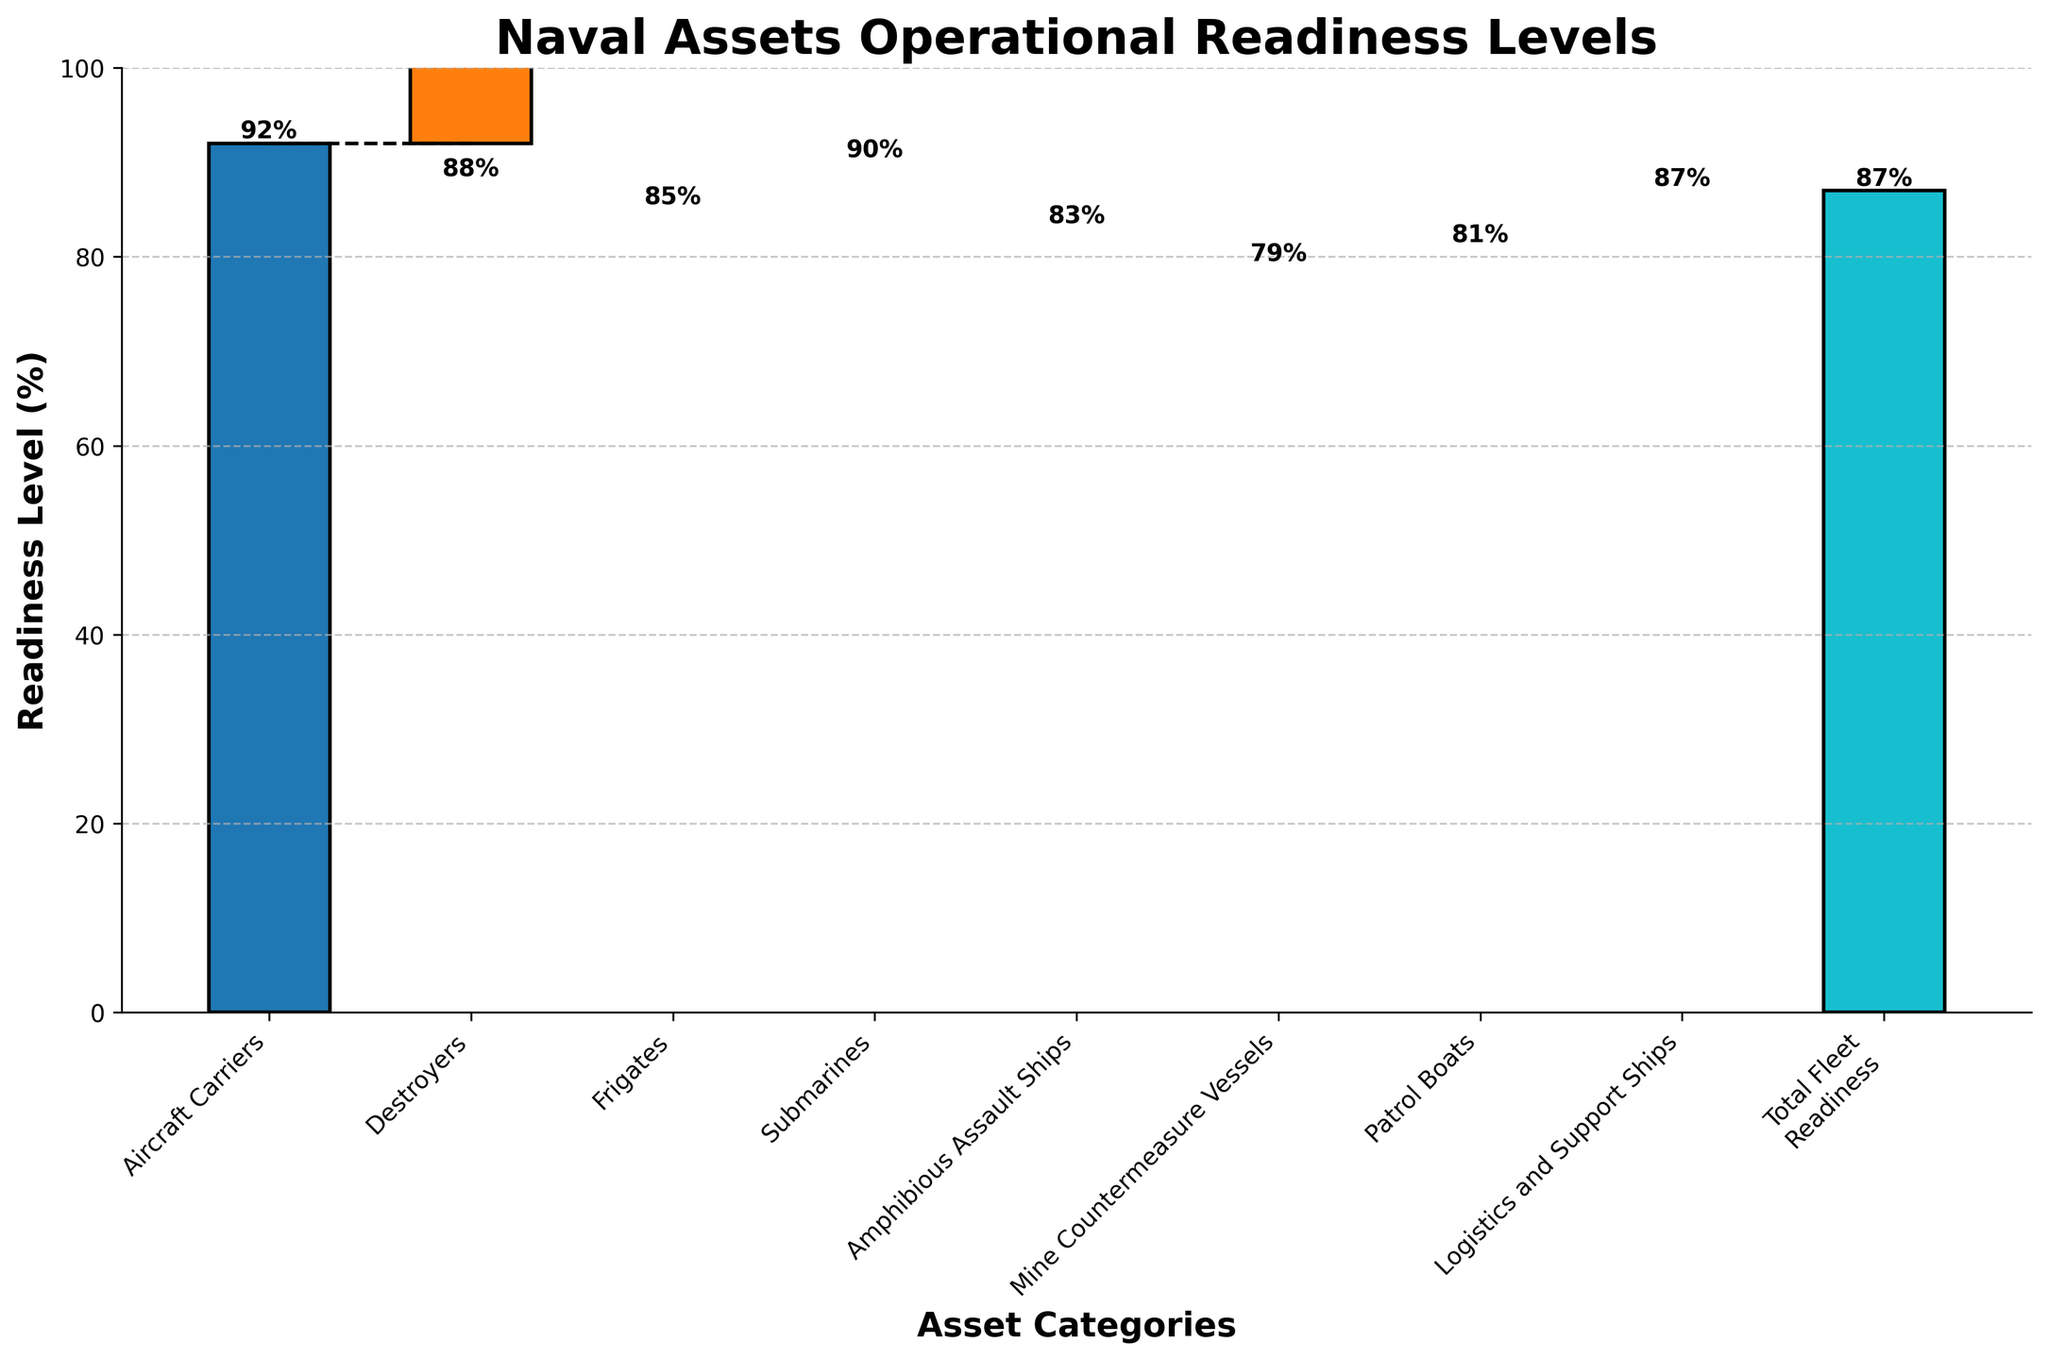How many asset categories are displayed in the chart? The chart shows the categories as bars on the x-axis and values for each bar. Counting the bars on the x-axis reveals the number of asset categories.
Answer: 8 Which asset category has the highest readiness level? Examine the heights of the bars; the tallest bar indicates the highest readiness level. The bar for Aircraft Carriers is the tallest.
Answer: Aircraft Carriers What is the title of the chart? The title is prominently displayed at the top of the chart.
Answer: Naval Assets Operational Readiness Levels What is the readiness level for Amphibious Assault Ships? The readiness levels are labeled above each bar. Find the label above the Amphibious Assault Ships bar.
Answer: 83 Calculate the average readiness level across all individual asset categories. Add the readiness levels of all individual categories and divide by the number of categories: (92 + 88 + 85 + 90 + 83 + 79 + 81 + 87) / 8.
Answer: 85.625 What is the difference in readiness levels between Submarines and Frigates? Find the readiness levels for Submarines and Frigates and subtract the smaller value from the larger one: 90 - 85.
Answer: 5 Which asset category has the lowest readiness level? Identify the shortest bar in the chart. The bar for Mine Countermeasure Vessels is the shortest.
Answer: Mine Countermeasure Vessels How does the readiness level of Logistics and Support Ships compare to that of Patrol Boats? Compare the heights of the respective bars. Logistics and Support Ships have a value of 87, while Patrol Boats have a value of 81. 87 is greater than 81.
Answer: Logistics and Support Ships have a higher readiness level than Patrol Boats What is the cumulative readiness level up to the Frigates category? Sum the readiness levels of Aircraft Carriers, Destroyers, and Frigates: 92 + 88 + 85.
Answer: 265 Explain the difference between the total fleet readiness and the sum of individual categories' readiness levels. Sum the individual readiness levels: 92 + 88 + 85 + 90 + 83 + 79 + 81 + 87 = 685. The total fleet readiness is given as 87; this appears to be an average or another metric rather than a sum.
Answer: The total fleet readiness likely represents an average or weighted average rather than a sum 